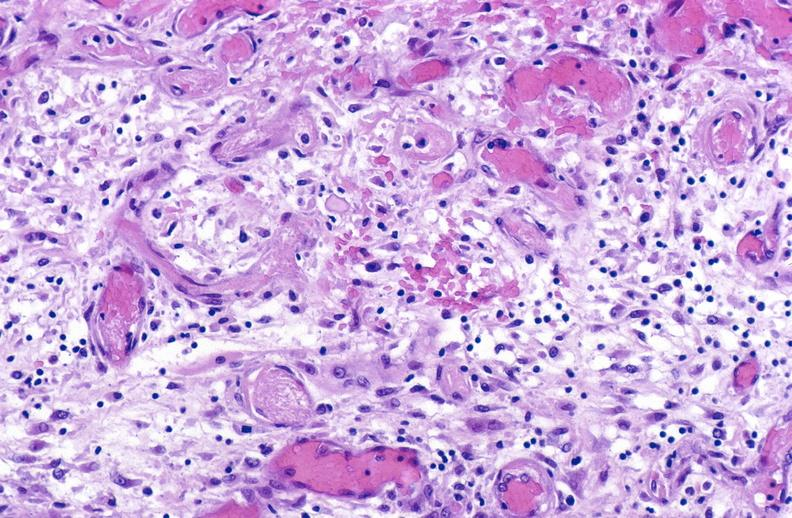what is present?
Answer the question using a single word or phrase. Muscle 